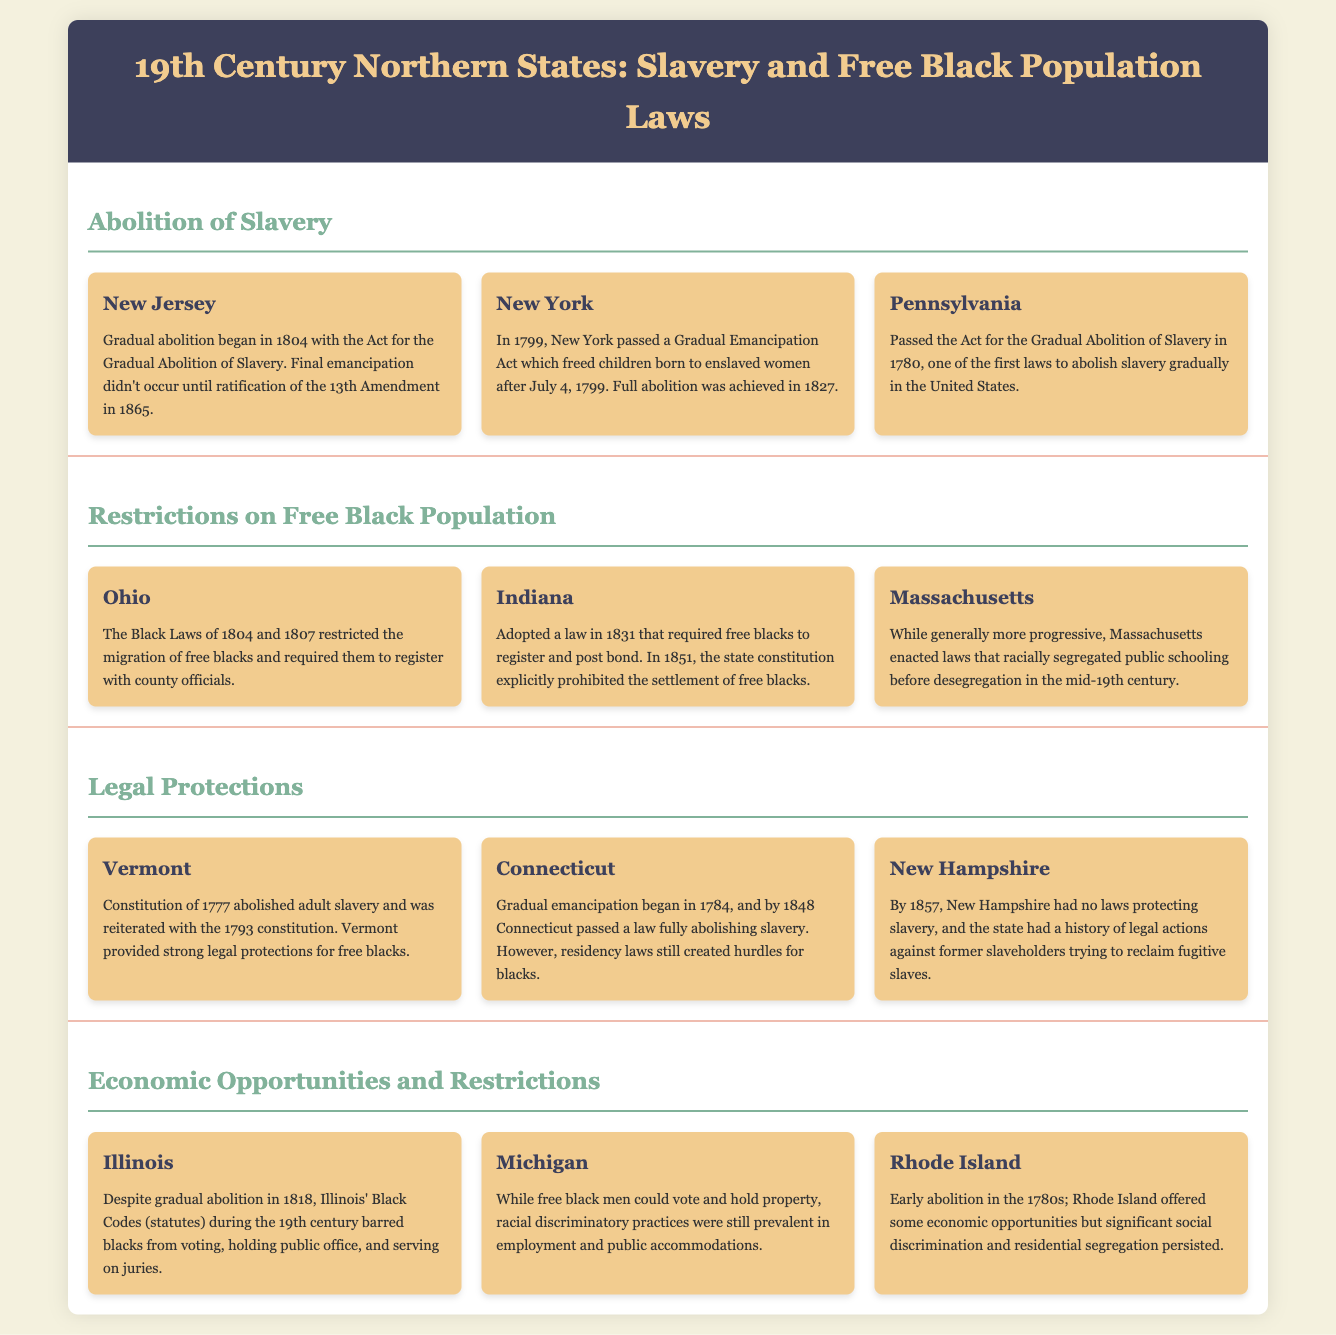what year did New Jersey begin gradual abolition? The document states that New Jersey's gradual abolition began in 1804.
Answer: 1804 which state fully abolished slavery in 1827? According to the document, New York achieved full abolition in 1827.
Answer: New York what were the Black Laws enacted in Ohio? The document describes the Black Laws of Ohio introduced in 1804 and 1807 that restricted the migration of free blacks.
Answer: The Black Laws which state provided strong legal protections for free blacks as noted in the document? The document indicates that Vermont provided strong legal protections for free blacks.
Answer: Vermont how many states are mentioned in the section about economic opportunities and restrictions? The document lists three states in the section regarding economic opportunities and restrictions.
Answer: Three what legislation did Indiana adopt in 1831 concerning free blacks? The document explains that Indiana adopted a law requiring free blacks to register and post bond in 1831.
Answer: Register and post bond which state has no laws protecting slavery by 1857? The document states that New Hampshire had no laws protecting slavery by 1857.
Answer: New Hampshire what type of economic opportunities did Rhode Island offer according to the document? The document notes that Rhode Island offered some economic opportunities following early abolition.
Answer: Some economic opportunities which state enacted laws that racially segregated public schooling? The document mentions that Massachusetts enacted laws that racially segregated public schooling.
Answer: Massachusetts 